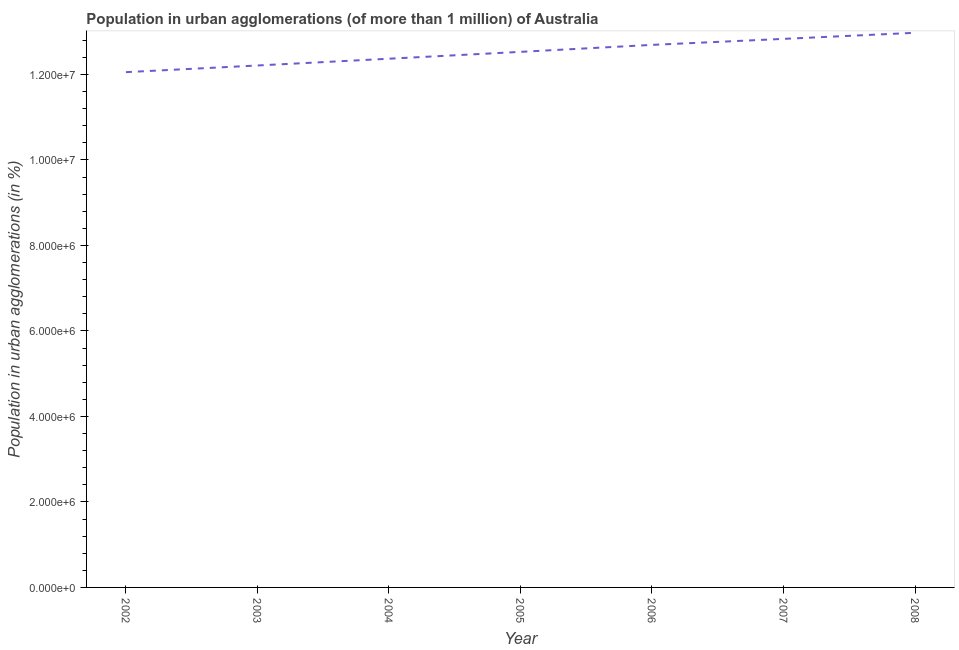What is the population in urban agglomerations in 2002?
Offer a very short reply. 1.21e+07. Across all years, what is the maximum population in urban agglomerations?
Offer a very short reply. 1.30e+07. Across all years, what is the minimum population in urban agglomerations?
Your answer should be compact. 1.21e+07. In which year was the population in urban agglomerations minimum?
Your response must be concise. 2002. What is the sum of the population in urban agglomerations?
Offer a very short reply. 8.77e+07. What is the difference between the population in urban agglomerations in 2005 and 2008?
Your answer should be compact. -4.46e+05. What is the average population in urban agglomerations per year?
Your answer should be very brief. 1.25e+07. What is the median population in urban agglomerations?
Provide a succinct answer. 1.25e+07. Do a majority of the years between 2005 and 2008 (inclusive) have population in urban agglomerations greater than 6000000 %?
Your response must be concise. Yes. What is the ratio of the population in urban agglomerations in 2006 to that in 2007?
Provide a succinct answer. 0.99. Is the population in urban agglomerations in 2002 less than that in 2008?
Your answer should be compact. Yes. What is the difference between the highest and the second highest population in urban agglomerations?
Offer a terse response. 1.42e+05. What is the difference between the highest and the lowest population in urban agglomerations?
Keep it short and to the point. 9.21e+05. Does the population in urban agglomerations monotonically increase over the years?
Keep it short and to the point. Yes. How many lines are there?
Your answer should be compact. 1. How many years are there in the graph?
Offer a terse response. 7. What is the difference between two consecutive major ticks on the Y-axis?
Offer a terse response. 2.00e+06. What is the title of the graph?
Your answer should be compact. Population in urban agglomerations (of more than 1 million) of Australia. What is the label or title of the X-axis?
Keep it short and to the point. Year. What is the label or title of the Y-axis?
Provide a short and direct response. Population in urban agglomerations (in %). What is the Population in urban agglomerations (in %) of 2002?
Provide a short and direct response. 1.21e+07. What is the Population in urban agglomerations (in %) of 2003?
Keep it short and to the point. 1.22e+07. What is the Population in urban agglomerations (in %) in 2004?
Ensure brevity in your answer.  1.24e+07. What is the Population in urban agglomerations (in %) in 2005?
Offer a very short reply. 1.25e+07. What is the Population in urban agglomerations (in %) in 2006?
Ensure brevity in your answer.  1.27e+07. What is the Population in urban agglomerations (in %) of 2007?
Your answer should be very brief. 1.28e+07. What is the Population in urban agglomerations (in %) of 2008?
Your answer should be compact. 1.30e+07. What is the difference between the Population in urban agglomerations (in %) in 2002 and 2003?
Your answer should be compact. -1.56e+05. What is the difference between the Population in urban agglomerations (in %) in 2002 and 2004?
Offer a very short reply. -3.14e+05. What is the difference between the Population in urban agglomerations (in %) in 2002 and 2005?
Keep it short and to the point. -4.75e+05. What is the difference between the Population in urban agglomerations (in %) in 2002 and 2006?
Your response must be concise. -6.38e+05. What is the difference between the Population in urban agglomerations (in %) in 2002 and 2007?
Provide a short and direct response. -7.78e+05. What is the difference between the Population in urban agglomerations (in %) in 2002 and 2008?
Offer a terse response. -9.21e+05. What is the difference between the Population in urban agglomerations (in %) in 2003 and 2004?
Provide a short and direct response. -1.59e+05. What is the difference between the Population in urban agglomerations (in %) in 2003 and 2005?
Your answer should be very brief. -3.19e+05. What is the difference between the Population in urban agglomerations (in %) in 2003 and 2006?
Your answer should be very brief. -4.82e+05. What is the difference between the Population in urban agglomerations (in %) in 2003 and 2007?
Offer a very short reply. -6.23e+05. What is the difference between the Population in urban agglomerations (in %) in 2003 and 2008?
Make the answer very short. -7.65e+05. What is the difference between the Population in urban agglomerations (in %) in 2004 and 2005?
Offer a terse response. -1.61e+05. What is the difference between the Population in urban agglomerations (in %) in 2004 and 2006?
Your response must be concise. -3.24e+05. What is the difference between the Population in urban agglomerations (in %) in 2004 and 2007?
Your answer should be compact. -4.64e+05. What is the difference between the Population in urban agglomerations (in %) in 2004 and 2008?
Your answer should be compact. -6.06e+05. What is the difference between the Population in urban agglomerations (in %) in 2005 and 2006?
Provide a short and direct response. -1.63e+05. What is the difference between the Population in urban agglomerations (in %) in 2005 and 2007?
Offer a terse response. -3.04e+05. What is the difference between the Population in urban agglomerations (in %) in 2005 and 2008?
Ensure brevity in your answer.  -4.46e+05. What is the difference between the Population in urban agglomerations (in %) in 2006 and 2007?
Make the answer very short. -1.40e+05. What is the difference between the Population in urban agglomerations (in %) in 2006 and 2008?
Keep it short and to the point. -2.83e+05. What is the difference between the Population in urban agglomerations (in %) in 2007 and 2008?
Your response must be concise. -1.42e+05. What is the ratio of the Population in urban agglomerations (in %) in 2002 to that in 2004?
Your response must be concise. 0.97. What is the ratio of the Population in urban agglomerations (in %) in 2002 to that in 2005?
Make the answer very short. 0.96. What is the ratio of the Population in urban agglomerations (in %) in 2002 to that in 2006?
Keep it short and to the point. 0.95. What is the ratio of the Population in urban agglomerations (in %) in 2002 to that in 2007?
Make the answer very short. 0.94. What is the ratio of the Population in urban agglomerations (in %) in 2002 to that in 2008?
Provide a succinct answer. 0.93. What is the ratio of the Population in urban agglomerations (in %) in 2003 to that in 2004?
Ensure brevity in your answer.  0.99. What is the ratio of the Population in urban agglomerations (in %) in 2003 to that in 2005?
Keep it short and to the point. 0.97. What is the ratio of the Population in urban agglomerations (in %) in 2003 to that in 2007?
Offer a terse response. 0.95. What is the ratio of the Population in urban agglomerations (in %) in 2003 to that in 2008?
Ensure brevity in your answer.  0.94. What is the ratio of the Population in urban agglomerations (in %) in 2004 to that in 2006?
Make the answer very short. 0.97. What is the ratio of the Population in urban agglomerations (in %) in 2004 to that in 2007?
Keep it short and to the point. 0.96. What is the ratio of the Population in urban agglomerations (in %) in 2004 to that in 2008?
Keep it short and to the point. 0.95. What is the ratio of the Population in urban agglomerations (in %) in 2005 to that in 2006?
Your answer should be very brief. 0.99. What is the ratio of the Population in urban agglomerations (in %) in 2005 to that in 2008?
Your answer should be very brief. 0.97. What is the ratio of the Population in urban agglomerations (in %) in 2006 to that in 2007?
Ensure brevity in your answer.  0.99. 